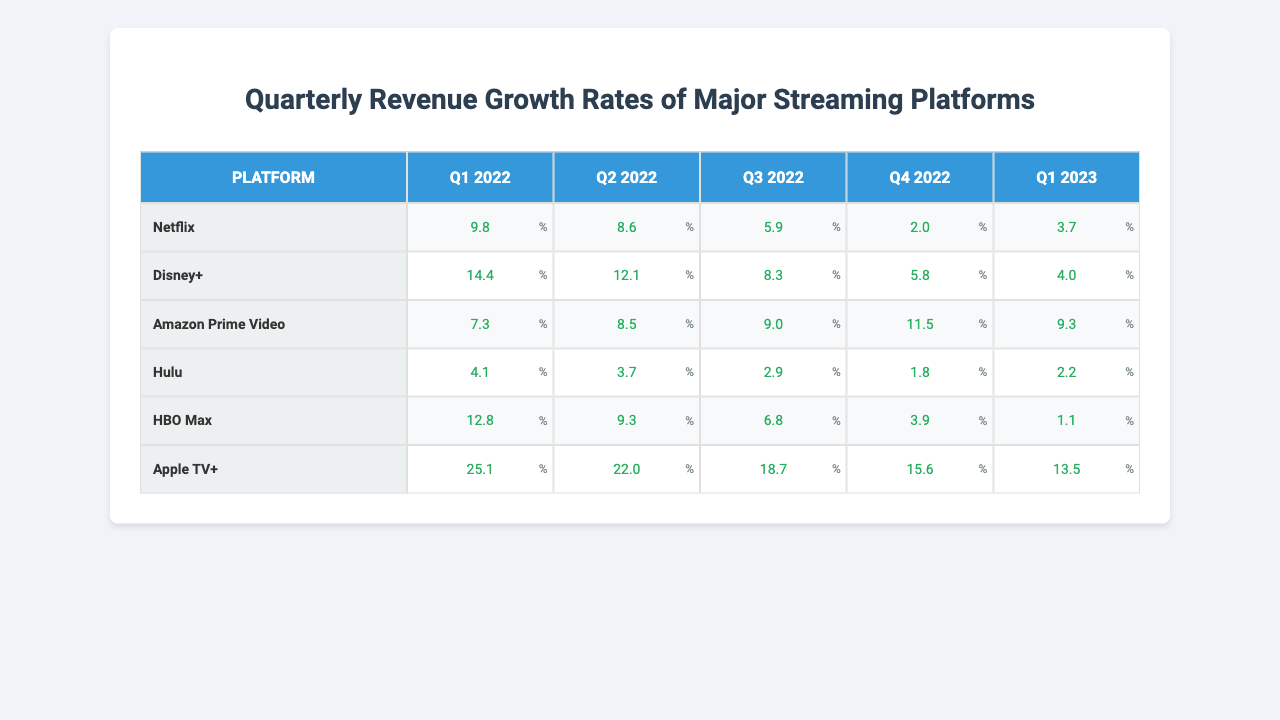What was Netflix's revenue growth rate in Q3 2022? The table shows that Netflix's growth rate for Q3 2022 is 5.9%.
Answer: 5.9% Which platform had the highest growth rate in Q1 2023? In Q1 2023, Apple TV+ had the highest growth rate at 13.5%.
Answer: 13.5% What is the average growth rate for Hulu across all quarters? To find the average, I sum Hulu's growth rates: (4.1 + 3.7 + 2.9 + 1.8 + 2.2) = 14.7. Dividing this by 5 gives an average of 2.94.
Answer: 2.94 Did Amazon Prime Video experience a revenue decline in any quarter? Looking at the growth rates, all values for Amazon Prime Video are positive, indicating there was no decline.
Answer: No What is the difference in growth rate between Disney+ in Q1 2022 and Q4 2022? Disney+'s growth rate was 14.4% in Q1 2022 and 5.8% in Q4 2022. The difference is 14.4 - 5.8 = 8.6%.
Answer: 8.6% Which platform had the least revenue growth in Q4 2022? In Q4 2022, Hulu had the lowest growth rate at 1.8%.
Answer: 1.8% What is the total growth rate for Netflix over all observed quarters? Summing Netflix's growth rates: 9.8 + 8.6 + 5.9 + 2.0 + 3.7 = 30.0%.
Answer: 30.0% Was the revenue growth for Disney+ in Q2 2022 higher than that of Hulu in the same quarter? Disney+ had 12.1% in Q2 2022, while Hulu had 3.7%. Since 12.1% is greater than 3.7%, the statement is true.
Answer: Yes Which platform showed a consistent decrease in growth from Q1 2022 to Q4 2022? Analyzing the growth rates, both Hulu and HBO Max show a declining trend over these quarters.
Answer: Hulu and HBO Max What was the combined growth rate for Apple TV+ in the first half of 2022? For the first half of 2022, Apple TV+'s growth rates were 25.1% in Q1 and 22.0% in Q2, yielding a combined growth of 25.1 + 22.0 = 47.1%.
Answer: 47.1% 